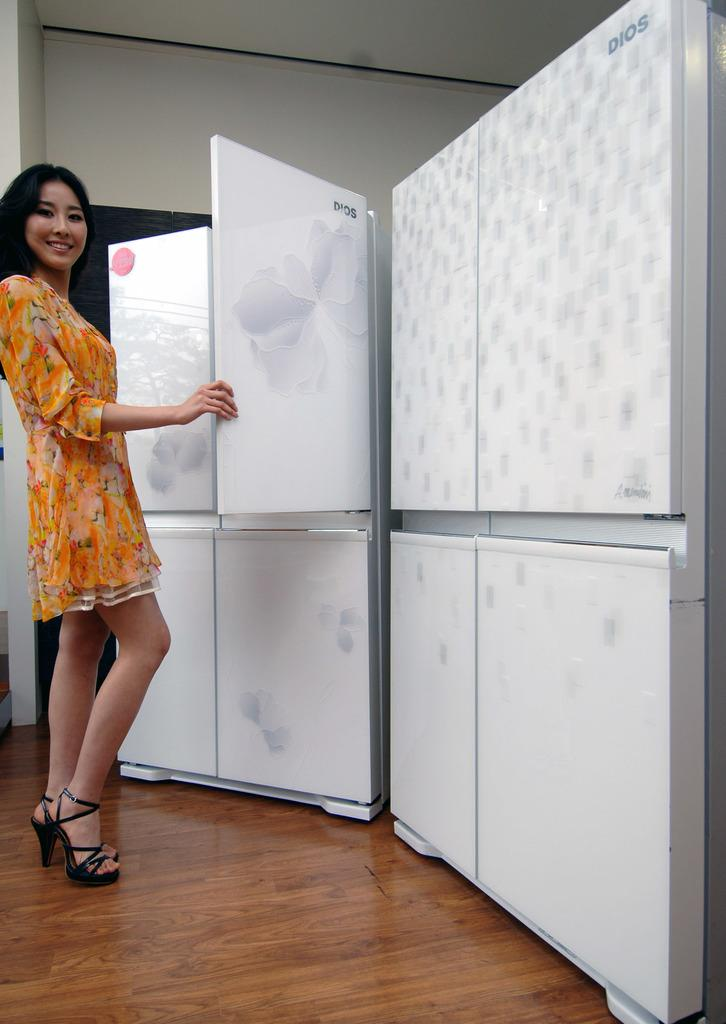Provide a one-sentence caption for the provided image. A female model opening the door of a Dios fridge. 